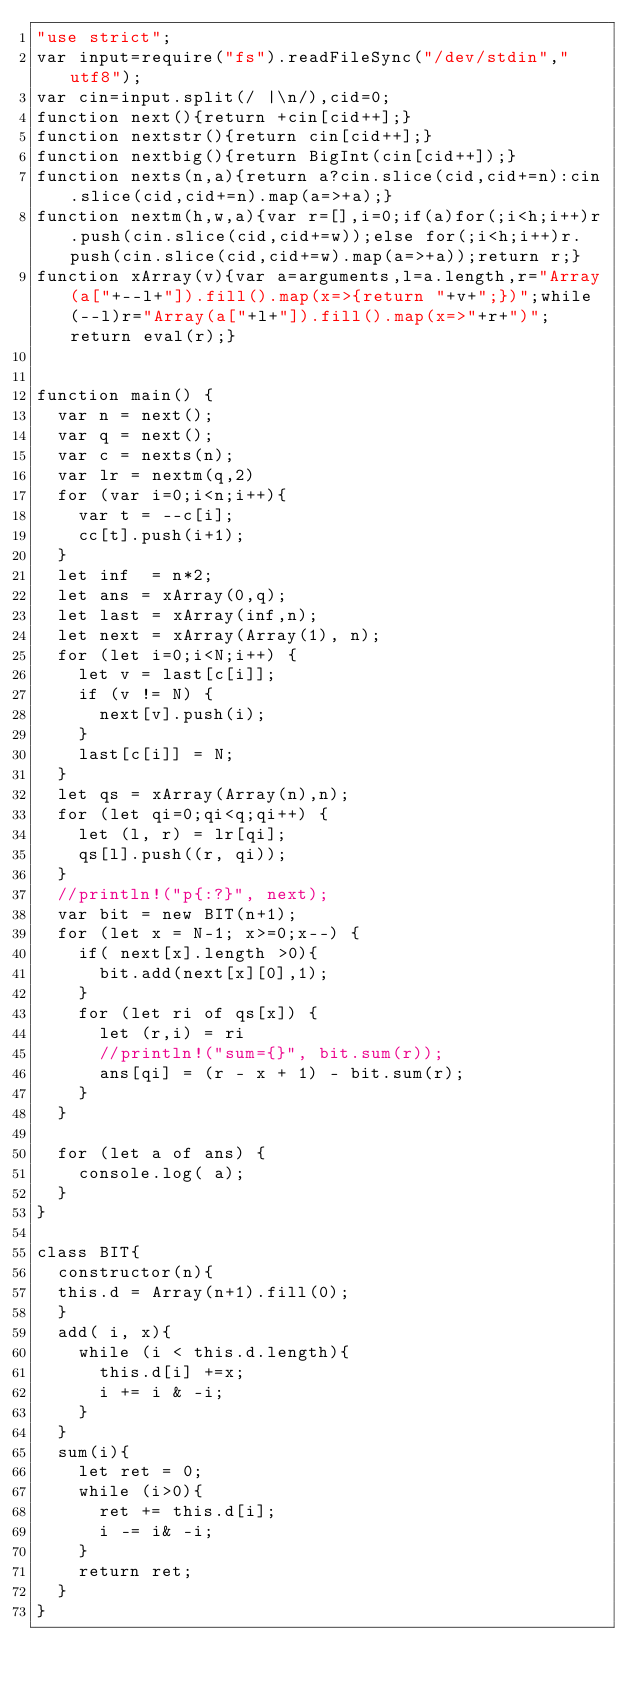<code> <loc_0><loc_0><loc_500><loc_500><_JavaScript_>"use strict";
var input=require("fs").readFileSync("/dev/stdin","utf8");
var cin=input.split(/ |\n/),cid=0;
function next(){return +cin[cid++];}
function nextstr(){return cin[cid++];}
function nextbig(){return BigInt(cin[cid++]);}
function nexts(n,a){return a?cin.slice(cid,cid+=n):cin.slice(cid,cid+=n).map(a=>+a);}
function nextm(h,w,a){var r=[],i=0;if(a)for(;i<h;i++)r.push(cin.slice(cid,cid+=w));else for(;i<h;i++)r.push(cin.slice(cid,cid+=w).map(a=>+a));return r;}
function xArray(v){var a=arguments,l=a.length,r="Array(a["+--l+"]).fill().map(x=>{return "+v+";})";while(--l)r="Array(a["+l+"]).fill().map(x=>"+r+")";return eval(r);}


function main() {
  var n = next();
  var q = next();
  var c = nexts(n);
  var lr = nextm(q,2)
  for (var i=0;i<n;i++){
    var t = --c[i];
    cc[t].push(i+1);
  }
  let inf  = n*2;
  let ans = xArray(0,q);
  let last = xArray(inf,n);
  let next = xArray(Array(1), n);
  for (let i=0;i<N;i++) {
    let v = last[c[i]];
    if (v != N) {
      next[v].push(i);
    }
    last[c[i]] = N;
  }
  let qs = xArray(Array(n),n);
  for (let qi=0;qi<q;qi++) {
    let (l, r) = lr[qi];
    qs[l].push((r, qi));
  }
  //println!("p{:?}", next);
  var bit = new BIT(n+1);
  for (let x = N-1; x>=0;x--) {
    if( next[x].length >0){
      bit.add(next[x][0],1);
    }
    for (let ri of qs[x]) {
      let (r,i) = ri
      //println!("sum={}", bit.sum(r));
      ans[qi] = (r - x + 1) - bit.sum(r);
    }
  }

  for (let a of ans) {
    console.log( a);
  }
}

class BIT{
  constructor(n){
  this.d = Array(n+1).fill(0);
  }
  add( i, x){
    while (i < this.d.length){
      this.d[i] +=x;
      i += i & -i;
    }
  }
  sum(i){
    let ret = 0;
    while (i>0){
      ret += this.d[i];
      i -= i& -i;
    }
    return ret;
  }
}
</code> 